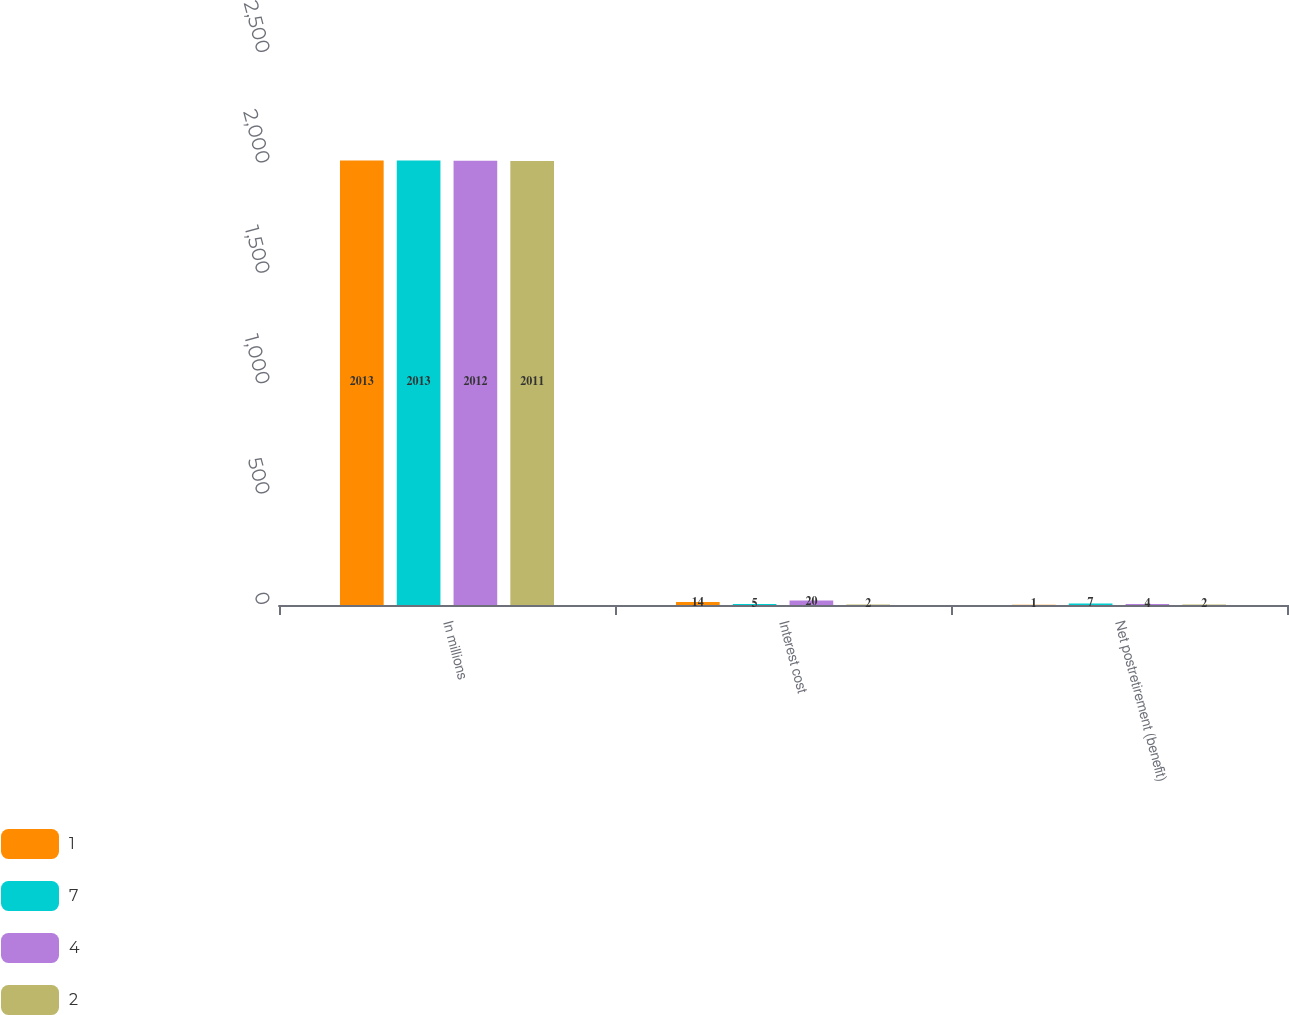<chart> <loc_0><loc_0><loc_500><loc_500><stacked_bar_chart><ecel><fcel>In millions<fcel>Interest cost<fcel>Net postretirement (benefit)<nl><fcel>1<fcel>2013<fcel>14<fcel>1<nl><fcel>7<fcel>2013<fcel>5<fcel>7<nl><fcel>4<fcel>2012<fcel>20<fcel>4<nl><fcel>2<fcel>2011<fcel>2<fcel>2<nl></chart> 